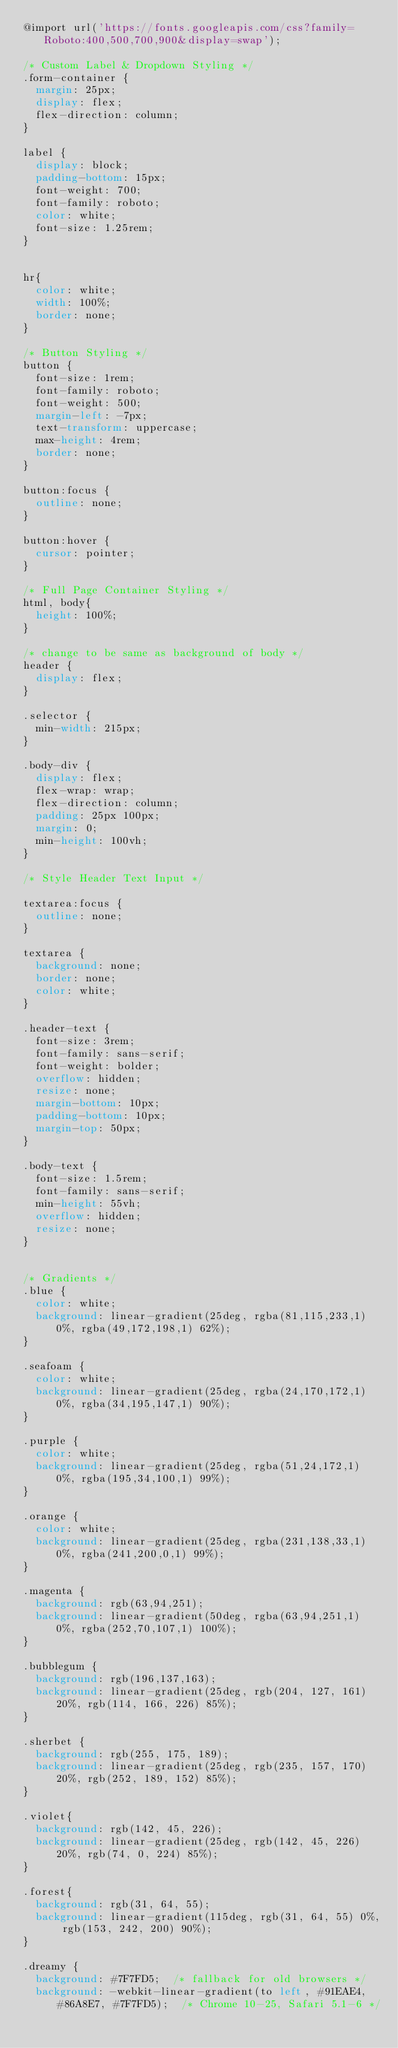<code> <loc_0><loc_0><loc_500><loc_500><_CSS_>@import url('https://fonts.googleapis.com/css?family=Roboto:400,500,700,900&display=swap');

/* Custom Label & Dropdown Styling */
.form-container {
  margin: 25px;
  display: flex;
  flex-direction: column;
}

label {
  display: block;
  padding-bottom: 15px;
  font-weight: 700;
  font-family: roboto;
  color: white;
  font-size: 1.25rem;
}


hr{
  color: white;
  width: 100%;
  border: none;
}

/* Button Styling */
button {
  font-size: 1rem;
  font-family: roboto;
  font-weight: 500;
  margin-left: -7px;
  text-transform: uppercase;
  max-height: 4rem;
  border: none;
}

button:focus {
  outline: none;
}

button:hover {
  cursor: pointer;
}

/* Full Page Container Styling */
html, body{
  height: 100%;
}

/* change to be same as background of body */
header {
  display: flex;
}

.selector {
  min-width: 215px;
}

.body-div {
  display: flex;
  flex-wrap: wrap;
  flex-direction: column;
  padding: 25px 100px;
  margin: 0;
  min-height: 100vh;
}

/* Style Header Text Input */

textarea:focus {
  outline: none;
}

textarea {
  background: none;
  border: none;
  color: white;
}

.header-text {
  font-size: 3rem;
  font-family: sans-serif;
  font-weight: bolder;
  overflow: hidden;
  resize: none;
  margin-bottom: 10px;
  padding-bottom: 10px;
  margin-top: 50px;
}

.body-text {
  font-size: 1.5rem;
  font-family: sans-serif;
  min-height: 55vh;
  overflow: hidden;
  resize: none;
}


/* Gradients */
.blue {
  color: white;
  background: linear-gradient(25deg, rgba(81,115,233,1) 0%, rgba(49,172,198,1) 62%);
}

.seafoam {
  color: white;
  background: linear-gradient(25deg, rgba(24,170,172,1) 0%, rgba(34,195,147,1) 90%);
}

.purple {
  color: white;
  background: linear-gradient(25deg, rgba(51,24,172,1) 0%, rgba(195,34,100,1) 99%);
}

.orange {
  color: white;
  background: linear-gradient(25deg, rgba(231,138,33,1) 0%, rgba(241,200,0,1) 99%);
}

.magenta {
  background: rgb(63,94,251);
  background: linear-gradient(50deg, rgba(63,94,251,1) 0%, rgba(252,70,107,1) 100%);
}

.bubblegum {
  background: rgb(196,137,163);
  background: linear-gradient(25deg, rgb(204, 127, 161) 20%, rgb(114, 166, 226) 85%);
}

.sherbet {
  background: rgb(255, 175, 189);
  background: linear-gradient(25deg, rgb(235, 157, 170) 20%, rgb(252, 189, 152) 85%);
}

.violet{
  background: rgb(142, 45, 226);
  background: linear-gradient(25deg, rgb(142, 45, 226) 20%, rgb(74, 0, 224) 85%);
}

.forest{
  background: rgb(31, 64, 55);
  background: linear-gradient(115deg, rgb(31, 64, 55) 0%, rgb(153, 242, 200) 90%);
}

.dreamy {
  background: #7F7FD5;  /* fallback for old browsers */
  background: -webkit-linear-gradient(to left, #91EAE4, #86A8E7, #7F7FD5);  /* Chrome 10-25, Safari 5.1-6 */</code> 